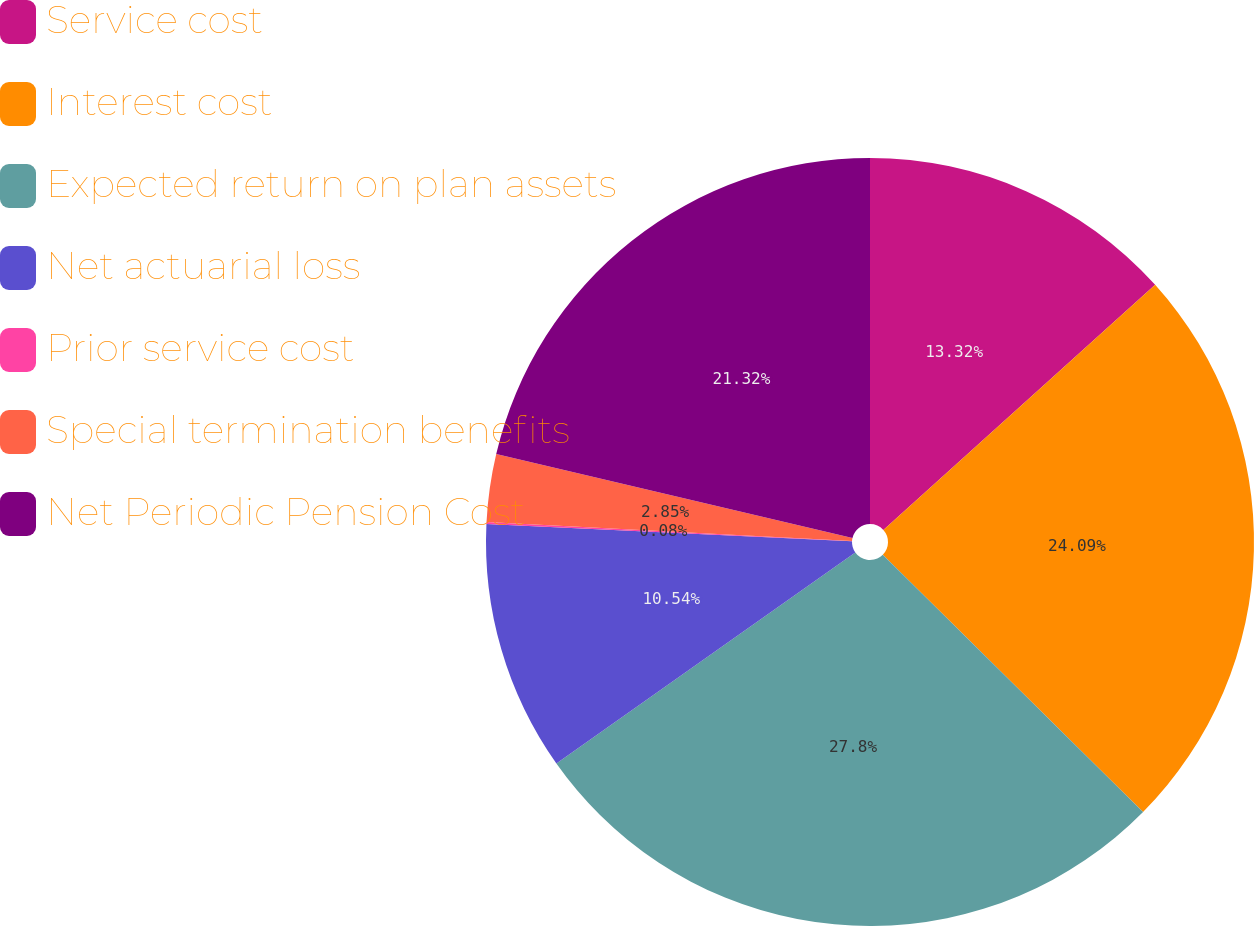Convert chart. <chart><loc_0><loc_0><loc_500><loc_500><pie_chart><fcel>Service cost<fcel>Interest cost<fcel>Expected return on plan assets<fcel>Net actuarial loss<fcel>Prior service cost<fcel>Special termination benefits<fcel>Net Periodic Pension Cost<nl><fcel>13.32%<fcel>24.09%<fcel>27.8%<fcel>10.54%<fcel>0.08%<fcel>2.85%<fcel>21.32%<nl></chart> 